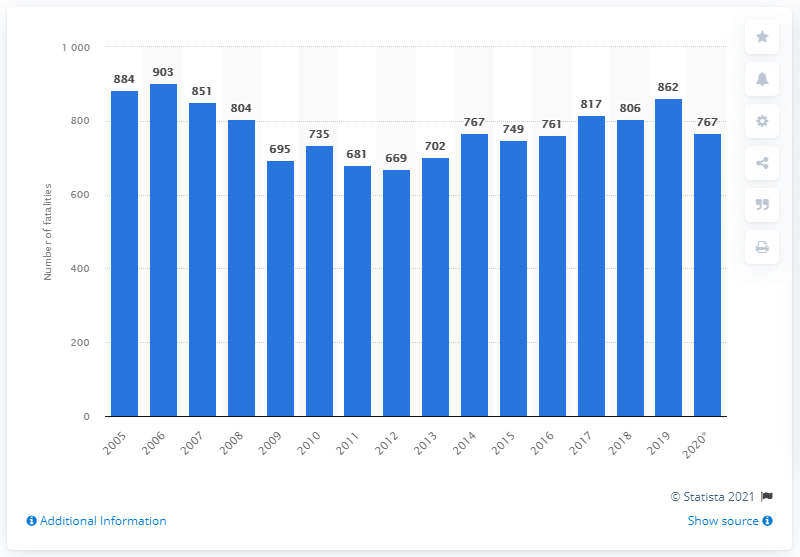Outline some significant characteristics in this image. In 2020, there were 767 rail fatalities in the United States. In 2013, the number of rail accidents and injuries was the lowest it has been since. 